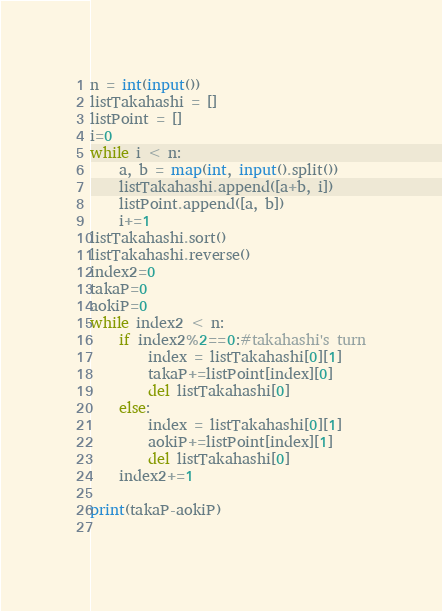Convert code to text. <code><loc_0><loc_0><loc_500><loc_500><_Python_>n = int(input())
listTakahashi = []
listPoint = []
i=0
while i < n:
    a, b = map(int, input().split())
    listTakahashi.append([a+b, i])
    listPoint.append([a, b])
    i+=1
listTakahashi.sort()
listTakahashi.reverse()
index2=0
takaP=0
aokiP=0
while index2 < n:
    if index2%2==0:#takahashi's turn
        index = listTakahashi[0][1]
        takaP+=listPoint[index][0]
        del listTakahashi[0]
    else:
        index = listTakahashi[0][1]
        aokiP+=listPoint[index][1]
        del listTakahashi[0]
    index2+=1

print(takaP-aokiP)
    </code> 